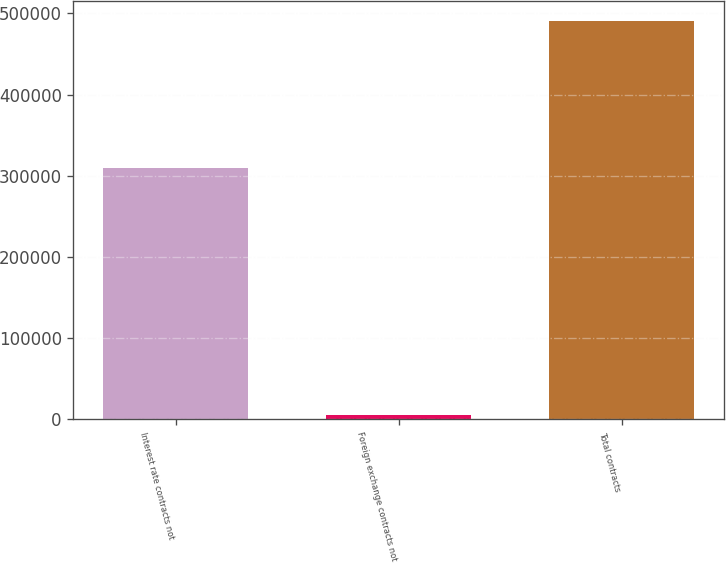<chart> <loc_0><loc_0><loc_500><loc_500><bar_chart><fcel>Interest rate contracts not<fcel>Foreign exchange contracts not<fcel>Total contracts<nl><fcel>309496<fcel>4885<fcel>490313<nl></chart> 